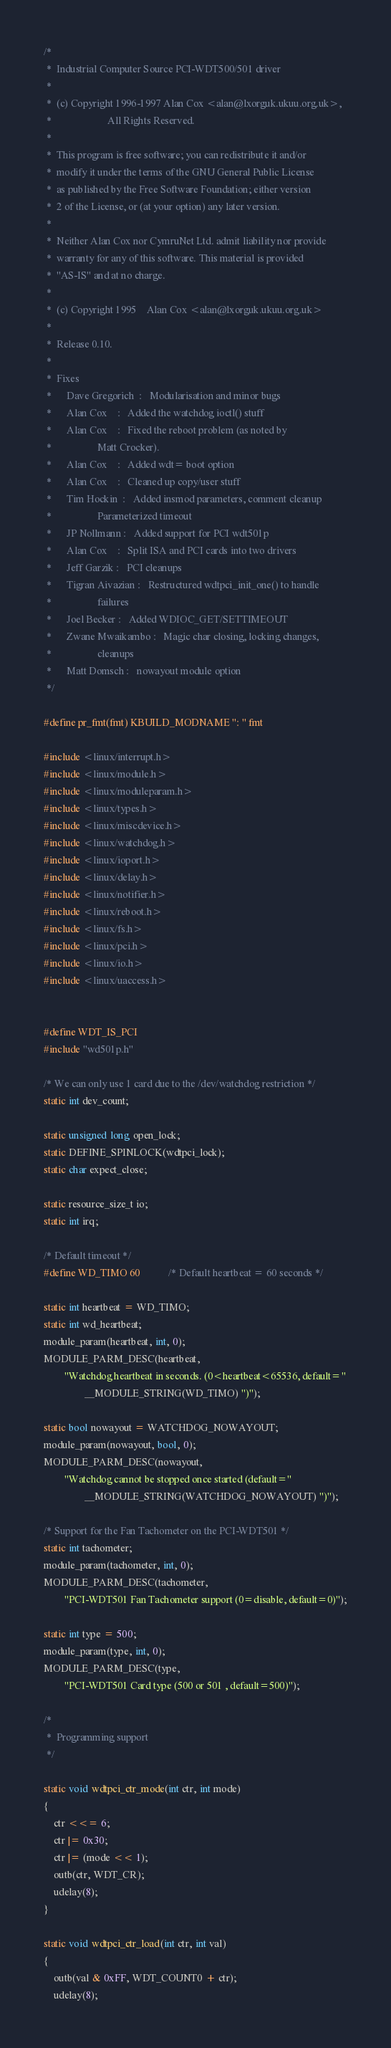<code> <loc_0><loc_0><loc_500><loc_500><_C_>/*
 *	Industrial Computer Source PCI-WDT500/501 driver
 *
 *	(c) Copyright 1996-1997 Alan Cox <alan@lxorguk.ukuu.org.uk>,
 *						All Rights Reserved.
 *
 *	This program is free software; you can redistribute it and/or
 *	modify it under the terms of the GNU General Public License
 *	as published by the Free Software Foundation; either version
 *	2 of the License, or (at your option) any later version.
 *
 *	Neither Alan Cox nor CymruNet Ltd. admit liability nor provide
 *	warranty for any of this software. This material is provided
 *	"AS-IS" and at no charge.
 *
 *	(c) Copyright 1995    Alan Cox <alan@lxorguk.ukuu.org.uk>
 *
 *	Release 0.10.
 *
 *	Fixes
 *		Dave Gregorich	:	Modularisation and minor bugs
 *		Alan Cox	:	Added the watchdog ioctl() stuff
 *		Alan Cox	:	Fixed the reboot problem (as noted by
 *					Matt Crocker).
 *		Alan Cox	:	Added wdt= boot option
 *		Alan Cox	:	Cleaned up copy/user stuff
 *		Tim Hockin	:	Added insmod parameters, comment cleanup
 *					Parameterized timeout
 *		JP Nollmann	:	Added support for PCI wdt501p
 *		Alan Cox	:	Split ISA and PCI cards into two drivers
 *		Jeff Garzik	:	PCI cleanups
 *		Tigran Aivazian	:	Restructured wdtpci_init_one() to handle
 *					failures
 *		Joel Becker	:	Added WDIOC_GET/SETTIMEOUT
 *		Zwane Mwaikambo	:	Magic char closing, locking changes,
 *					cleanups
 *		Matt Domsch	:	nowayout module option
 */

#define pr_fmt(fmt) KBUILD_MODNAME ": " fmt

#include <linux/interrupt.h>
#include <linux/module.h>
#include <linux/moduleparam.h>
#include <linux/types.h>
#include <linux/miscdevice.h>
#include <linux/watchdog.h>
#include <linux/ioport.h>
#include <linux/delay.h>
#include <linux/notifier.h>
#include <linux/reboot.h>
#include <linux/fs.h>
#include <linux/pci.h>
#include <linux/io.h>
#include <linux/uaccess.h>


#define WDT_IS_PCI
#include "wd501p.h"

/* We can only use 1 card due to the /dev/watchdog restriction */
static int dev_count;

static unsigned long open_lock;
static DEFINE_SPINLOCK(wdtpci_lock);
static char expect_close;

static resource_size_t io;
static int irq;

/* Default timeout */
#define WD_TIMO 60			/* Default heartbeat = 60 seconds */

static int heartbeat = WD_TIMO;
static int wd_heartbeat;
module_param(heartbeat, int, 0);
MODULE_PARM_DESC(heartbeat,
		"Watchdog heartbeat in seconds. (0<heartbeat<65536, default="
				__MODULE_STRING(WD_TIMO) ")");

static bool nowayout = WATCHDOG_NOWAYOUT;
module_param(nowayout, bool, 0);
MODULE_PARM_DESC(nowayout,
		"Watchdog cannot be stopped once started (default="
				__MODULE_STRING(WATCHDOG_NOWAYOUT) ")");

/* Support for the Fan Tachometer on the PCI-WDT501 */
static int tachometer;
module_param(tachometer, int, 0);
MODULE_PARM_DESC(tachometer,
		"PCI-WDT501 Fan Tachometer support (0=disable, default=0)");

static int type = 500;
module_param(type, int, 0);
MODULE_PARM_DESC(type,
		"PCI-WDT501 Card type (500 or 501 , default=500)");

/*
 *	Programming support
 */

static void wdtpci_ctr_mode(int ctr, int mode)
{
	ctr <<= 6;
	ctr |= 0x30;
	ctr |= (mode << 1);
	outb(ctr, WDT_CR);
	udelay(8);
}

static void wdtpci_ctr_load(int ctr, int val)
{
	outb(val & 0xFF, WDT_COUNT0 + ctr);
	udelay(8);</code> 